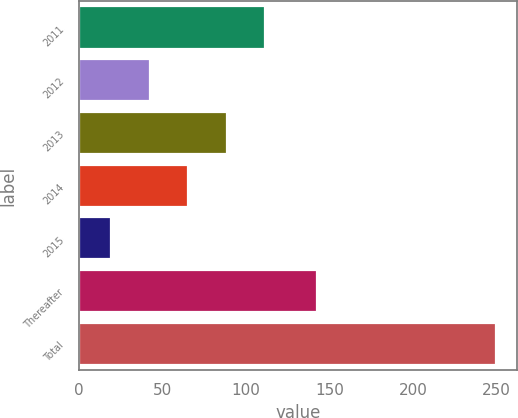Convert chart. <chart><loc_0><loc_0><loc_500><loc_500><bar_chart><fcel>2011<fcel>2012<fcel>2013<fcel>2014<fcel>2015<fcel>Thereafter<fcel>Total<nl><fcel>111.56<fcel>42.44<fcel>88.52<fcel>65.48<fcel>19.4<fcel>142.5<fcel>249.8<nl></chart> 